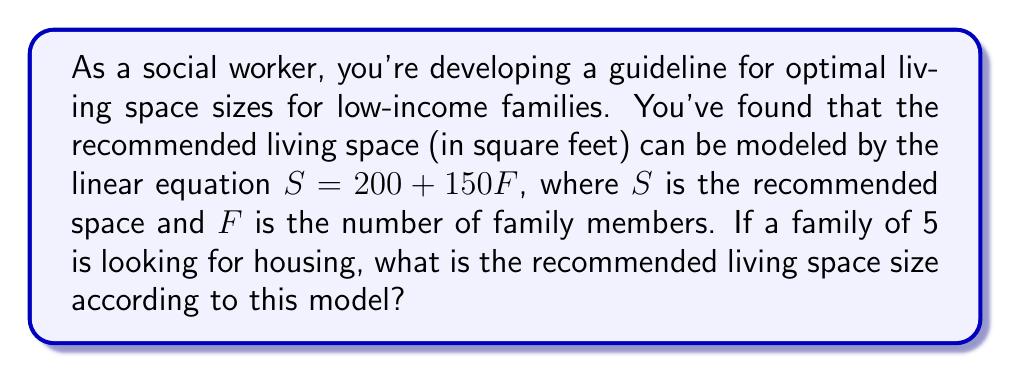Show me your answer to this math problem. Let's approach this step-by-step:

1) We're given the linear equation: $S = 200 + 150F$
   Where $S$ is the recommended space in square feet, and $F$ is the number of family members.

2) We need to find $S$ for a family of 5, so we'll substitute $F = 5$ into our equation:

   $S = 200 + 150(5)$

3) Now let's solve this equation:
   $S = 200 + 750$
   $S = 950$

Therefore, the recommended living space for a family of 5 is 950 square feet.
Answer: 950 square feet 